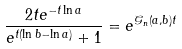Convert formula to latex. <formula><loc_0><loc_0><loc_500><loc_500>\frac { 2 t e ^ { - t \ln a } } { e ^ { t ( \ln b - \ln a ) } + 1 } = e ^ { \mathcal { G } _ { n } ( a , b ) t }</formula> 